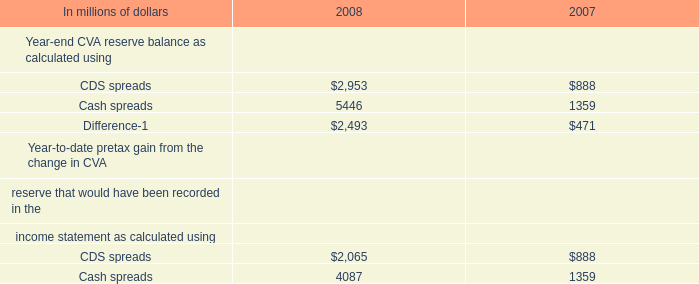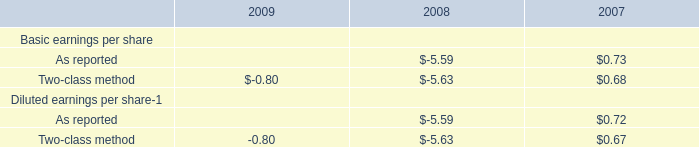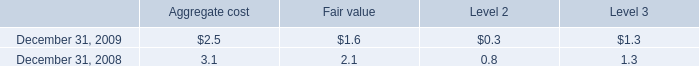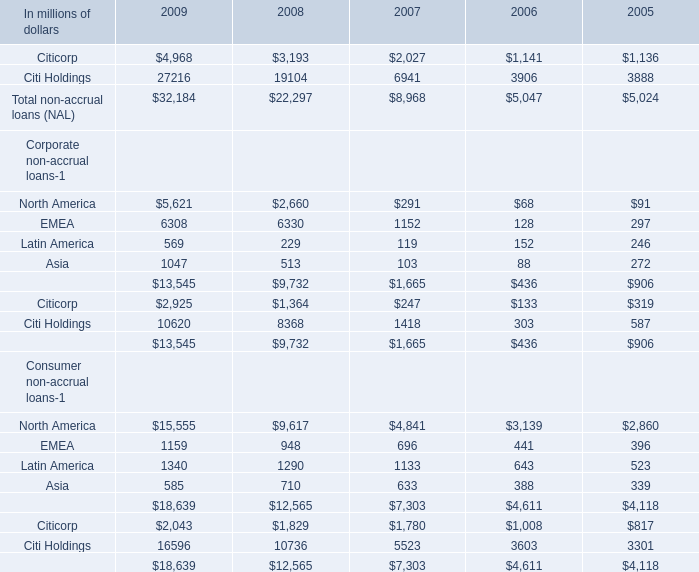what was the ratio of the net increase in the in securities sold under agreements to repurchase to the net transfers in 
Computations: (5 / 6.2)
Answer: 0.80645. 